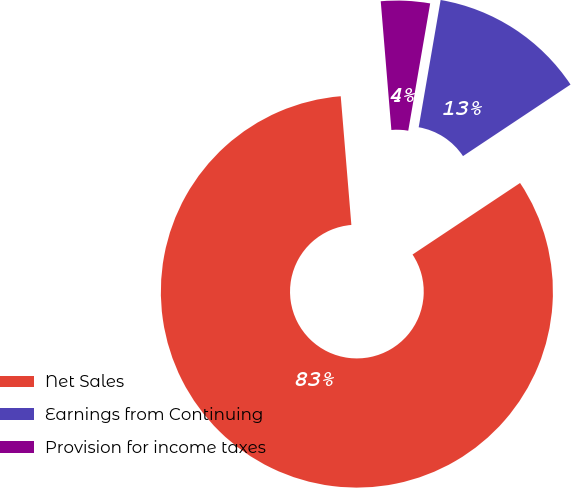Convert chart. <chart><loc_0><loc_0><loc_500><loc_500><pie_chart><fcel>Net Sales<fcel>Earnings from Continuing<fcel>Provision for income taxes<nl><fcel>83.04%<fcel>12.94%<fcel>4.03%<nl></chart> 